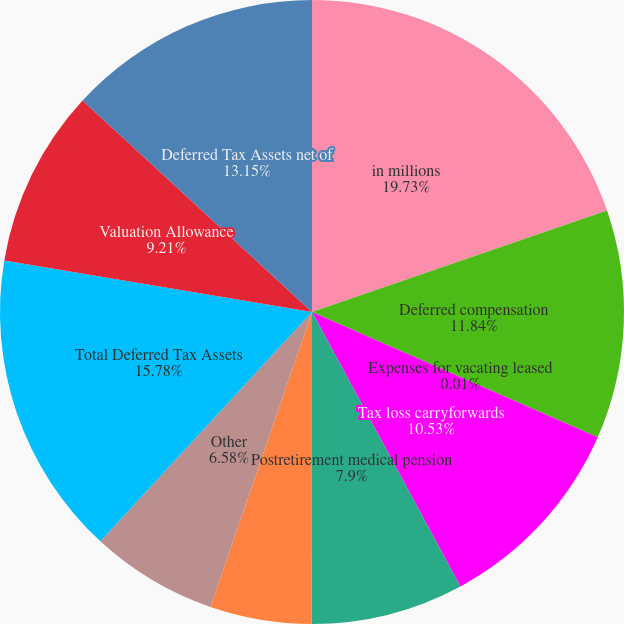Convert chart. <chart><loc_0><loc_0><loc_500><loc_500><pie_chart><fcel>in millions<fcel>Deferred compensation<fcel>Expenses for vacating leased<fcel>Tax loss carryforwards<fcel>Postretirement medical pension<fcel>Investment basis differences<fcel>Other<fcel>Total Deferred Tax Assets<fcel>Valuation Allowance<fcel>Deferred Tax Assets net of<nl><fcel>19.73%<fcel>11.84%<fcel>0.01%<fcel>10.53%<fcel>7.9%<fcel>5.27%<fcel>6.58%<fcel>15.78%<fcel>9.21%<fcel>13.15%<nl></chart> 